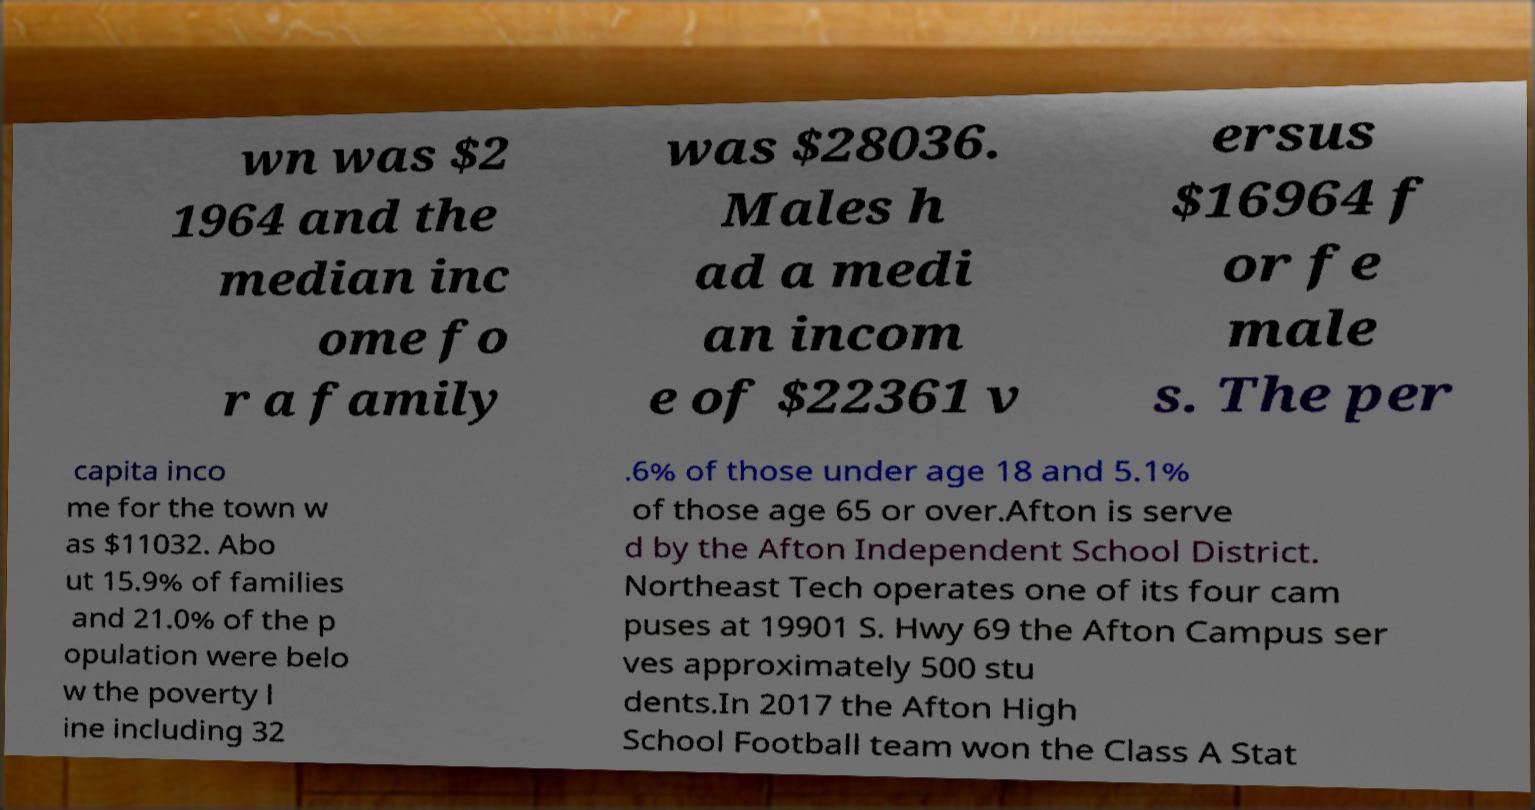There's text embedded in this image that I need extracted. Can you transcribe it verbatim? wn was $2 1964 and the median inc ome fo r a family was $28036. Males h ad a medi an incom e of $22361 v ersus $16964 f or fe male s. The per capita inco me for the town w as $11032. Abo ut 15.9% of families and 21.0% of the p opulation were belo w the poverty l ine including 32 .6% of those under age 18 and 5.1% of those age 65 or over.Afton is serve d by the Afton Independent School District. Northeast Tech operates one of its four cam puses at 19901 S. Hwy 69 the Afton Campus ser ves approximately 500 stu dents.In 2017 the Afton High School Football team won the Class A Stat 